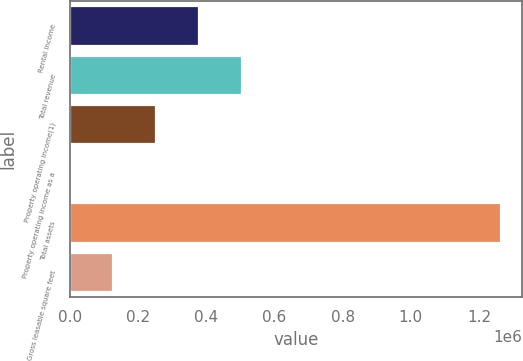Convert chart. <chart><loc_0><loc_0><loc_500><loc_500><bar_chart><fcel>Rental income<fcel>Total revenue<fcel>Property operating income(1)<fcel>Property operating income as a<fcel>Total assets<fcel>Gross leasable square feet<nl><fcel>379289<fcel>505696<fcel>252882<fcel>69.3<fcel>1.26414e+06<fcel>126476<nl></chart> 